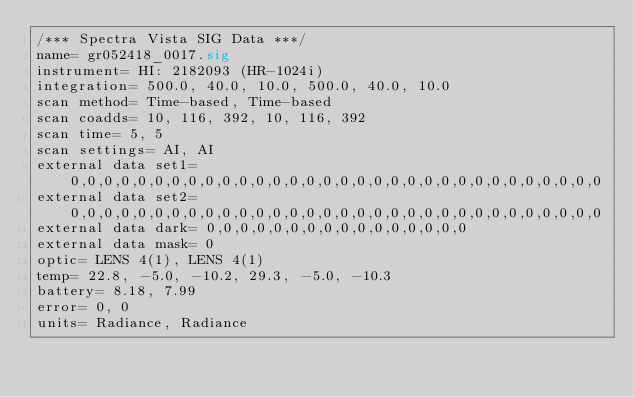<code> <loc_0><loc_0><loc_500><loc_500><_SML_>/*** Spectra Vista SIG Data ***/
name= gr052418_0017.sig
instrument= HI: 2182093 (HR-1024i)
integration= 500.0, 40.0, 10.0, 500.0, 40.0, 10.0
scan method= Time-based, Time-based
scan coadds= 10, 116, 392, 10, 116, 392
scan time= 5, 5
scan settings= AI, AI
external data set1= 0,0,0,0,0,0,0,0,0,0,0,0,0,0,0,0,0,0,0,0,0,0,0,0,0,0,0,0,0,0,0,0
external data set2= 0,0,0,0,0,0,0,0,0,0,0,0,0,0,0,0,0,0,0,0,0,0,0,0,0,0,0,0,0,0,0,0
external data dark= 0,0,0,0,0,0,0,0,0,0,0,0,0,0,0,0
external data mask= 0
optic= LENS 4(1), LENS 4(1)
temp= 22.8, -5.0, -10.2, 29.3, -5.0, -10.3
battery= 8.18, 7.99
error= 0, 0
units= Radiance, Radiance</code> 